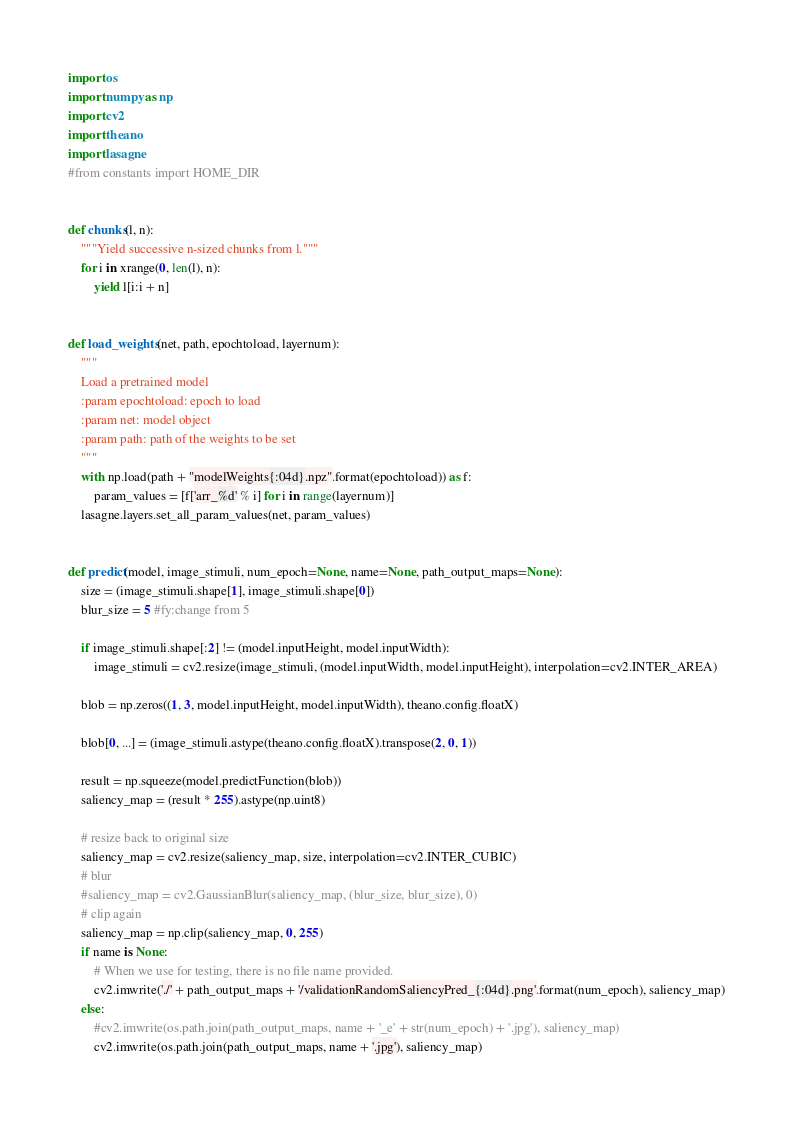<code> <loc_0><loc_0><loc_500><loc_500><_Python_>import os
import numpy as np
import cv2
import theano
import lasagne
#from constants import HOME_DIR


def chunks(l, n):
    """Yield successive n-sized chunks from l."""
    for i in xrange(0, len(l), n):
        yield l[i:i + n]


def load_weights(net, path, epochtoload, layernum):
    """
    Load a pretrained model
    :param epochtoload: epoch to load
    :param net: model object
    :param path: path of the weights to be set
    """
    with np.load(path + "modelWeights{:04d}.npz".format(epochtoload)) as f:
        param_values = [f['arr_%d' % i] for i in range(layernum)]
    lasagne.layers.set_all_param_values(net, param_values)


def predict(model, image_stimuli, num_epoch=None, name=None, path_output_maps=None):
    size = (image_stimuli.shape[1], image_stimuli.shape[0])
    blur_size = 5 #fy:change from 5

    if image_stimuli.shape[:2] != (model.inputHeight, model.inputWidth):
        image_stimuli = cv2.resize(image_stimuli, (model.inputWidth, model.inputHeight), interpolation=cv2.INTER_AREA)

    blob = np.zeros((1, 3, model.inputHeight, model.inputWidth), theano.config.floatX)

    blob[0, ...] = (image_stimuli.astype(theano.config.floatX).transpose(2, 0, 1))

    result = np.squeeze(model.predictFunction(blob))
    saliency_map = (result * 255).astype(np.uint8)

    # resize back to original size
    saliency_map = cv2.resize(saliency_map, size, interpolation=cv2.INTER_CUBIC)
    # blur
    #saliency_map = cv2.GaussianBlur(saliency_map, (blur_size, blur_size), 0)
    # clip again
    saliency_map = np.clip(saliency_map, 0, 255)
    if name is None:
        # When we use for testing, there is no file name provided.
        cv2.imwrite('./' + path_output_maps + '/validationRandomSaliencyPred_{:04d}.png'.format(num_epoch), saliency_map)
    else:
        #cv2.imwrite(os.path.join(path_output_maps, name + '_e' + str(num_epoch) + '.jpg'), saliency_map)
        cv2.imwrite(os.path.join(path_output_maps, name + '.jpg'), saliency_map)


</code> 